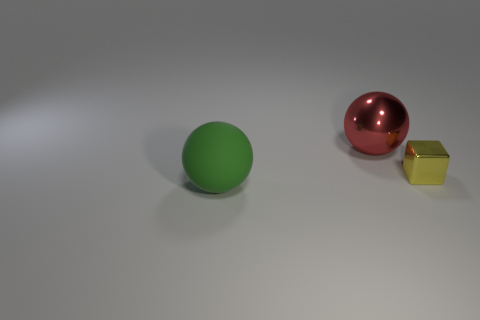Add 2 small yellow metallic spheres. How many objects exist? 5 Subtract all red spheres. How many spheres are left? 1 Subtract all cubes. How many objects are left? 2 Subtract all brown cubes. Subtract all brown cylinders. How many cubes are left? 1 Subtract all red cylinders. How many green spheres are left? 1 Subtract all small gray blocks. Subtract all big matte spheres. How many objects are left? 2 Add 1 tiny yellow blocks. How many tiny yellow blocks are left? 2 Add 1 brown shiny cylinders. How many brown shiny cylinders exist? 1 Subtract 0 blue cubes. How many objects are left? 3 Subtract 1 spheres. How many spheres are left? 1 